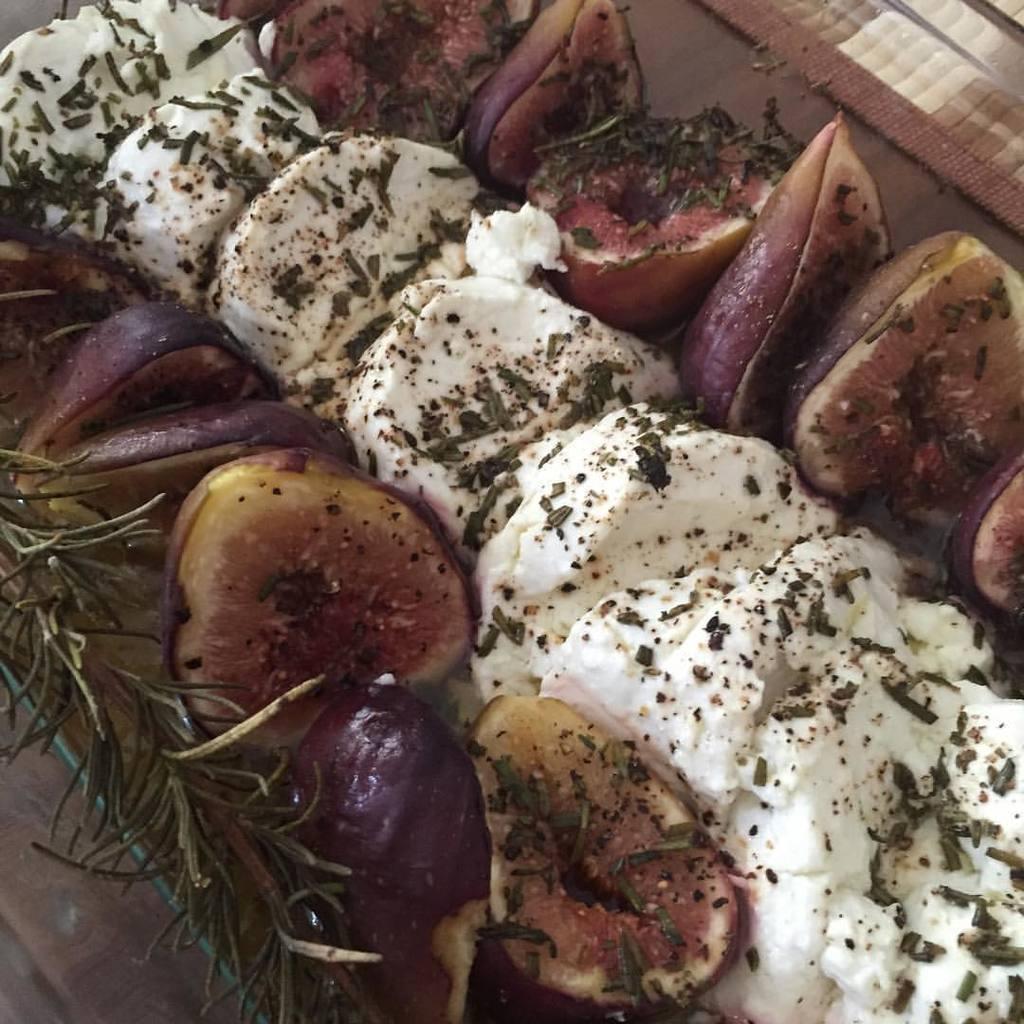How would you summarize this image in a sentence or two? In this image we can see food. 